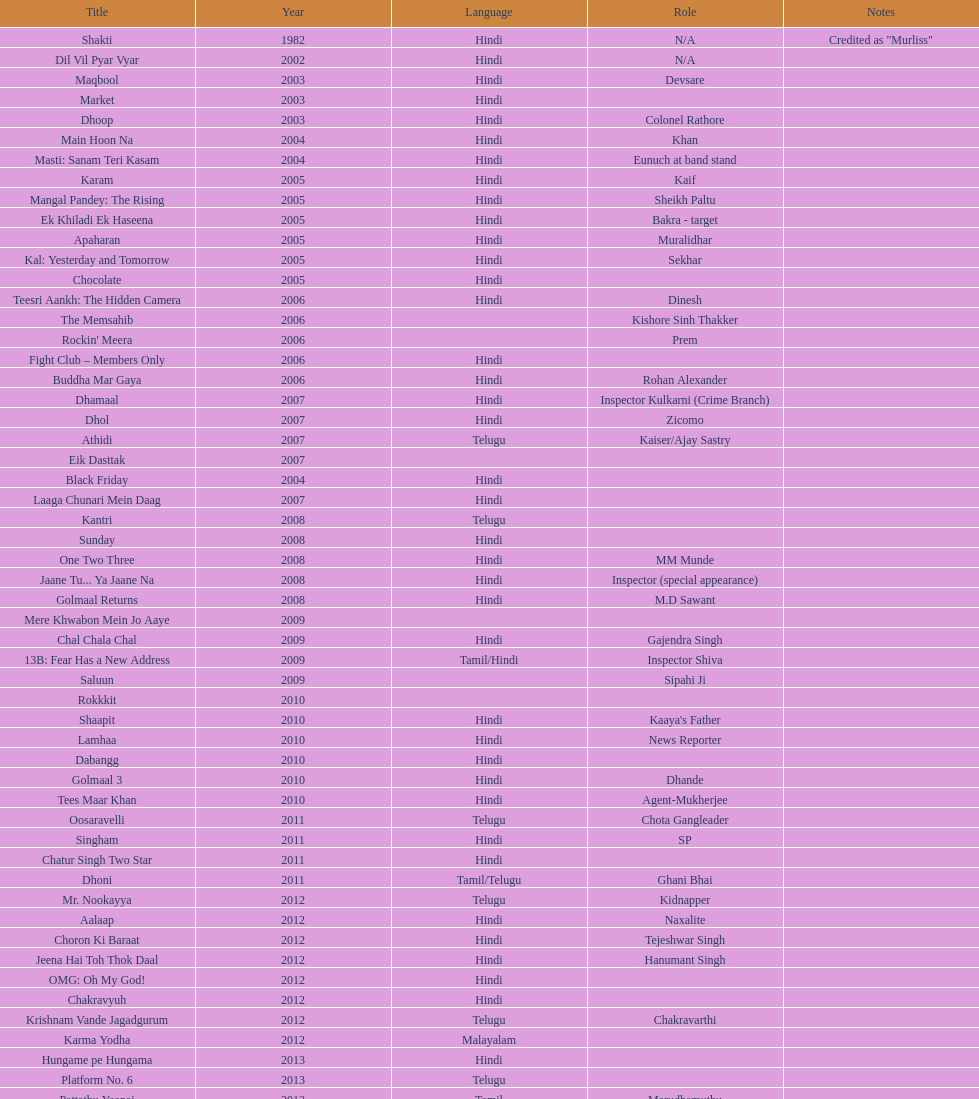In which latest malayalam film did this actor appear? Karma Yodha. 